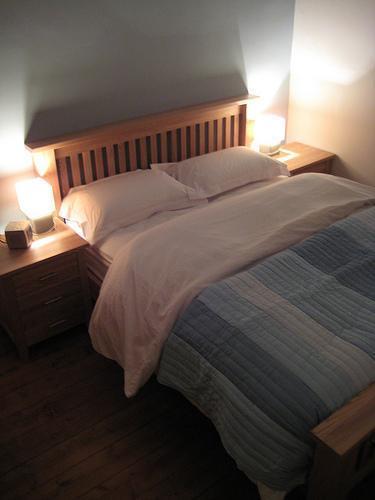How many lights do you see in the picture?
Give a very brief answer. 2. How many pillows are there?
Give a very brief answer. 2. How many drawers are there?
Give a very brief answer. 3. How many nightstand does the drawer have?
Give a very brief answer. 3. 